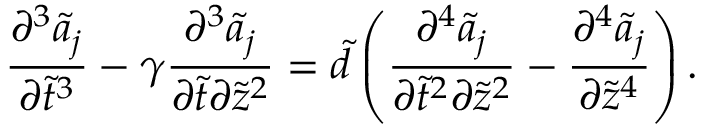<formula> <loc_0><loc_0><loc_500><loc_500>\frac { \partial ^ { 3 } \widetilde { a } _ { j } } { \partial \tilde { t } ^ { 3 } } - \gamma \frac { \partial ^ { 3 } \widetilde { a } _ { j } } { \partial \tilde { t } \partial \tilde { z } ^ { 2 } } = \widetilde { d } \left ( \frac { \partial ^ { 4 } \widetilde { a } _ { j } } { \partial \tilde { t } ^ { 2 } \partial \tilde { z } ^ { 2 } } - \frac { \partial ^ { 4 } \widetilde { a } _ { j } } { \partial \tilde { z } ^ { 4 } } \right ) .</formula> 